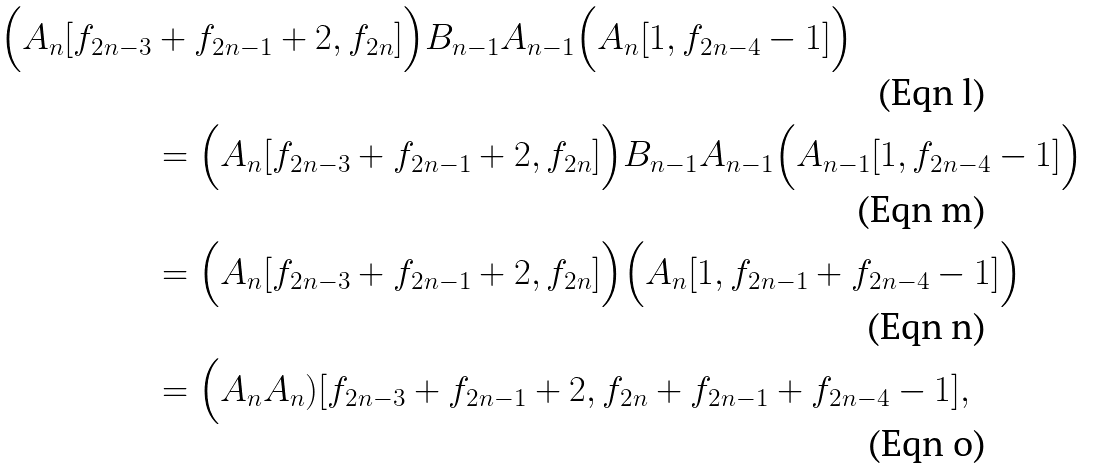<formula> <loc_0><loc_0><loc_500><loc_500>\Big ( A _ { n } [ f _ { 2 n - 3 } & + f _ { 2 n - 1 } + 2 , f _ { 2 n } ] \Big ) B _ { n - 1 } A _ { n - 1 } \Big ( A _ { n } [ 1 , f _ { 2 n - 4 } - 1 ] \Big ) \\ & = \Big ( A _ { n } [ f _ { 2 n - 3 } + f _ { 2 n - 1 } + 2 , f _ { 2 n } ] \Big ) B _ { n - 1 } A _ { n - 1 } \Big ( A _ { n - 1 } [ 1 , f _ { 2 n - 4 } - 1 ] \Big ) \\ & = \Big ( A _ { n } [ f _ { 2 n - 3 } + f _ { 2 n - 1 } + 2 , f _ { 2 n } ] \Big ) \Big ( A _ { n } [ 1 , f _ { 2 n - 1 } + f _ { 2 n - 4 } - 1 ] \Big ) \\ & = \Big ( A _ { n } A _ { n } ) [ f _ { 2 n - 3 } + f _ { 2 n - 1 } + 2 , f _ { 2 n } + f _ { 2 n - 1 } + f _ { 2 n - 4 } - 1 ] ,</formula> 